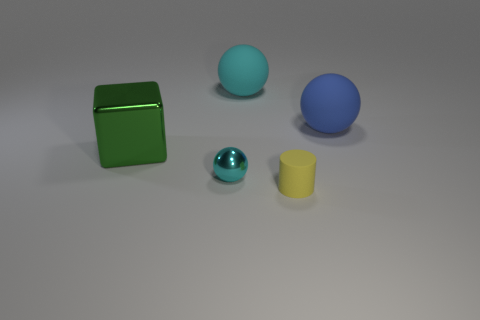Add 3 large green metallic blocks. How many objects exist? 8 Subtract all spheres. How many objects are left? 2 Add 2 tiny cyan shiny balls. How many tiny cyan shiny balls exist? 3 Subtract 1 blue spheres. How many objects are left? 4 Subtract all cyan balls. Subtract all cyan shiny things. How many objects are left? 2 Add 3 large things. How many large things are left? 6 